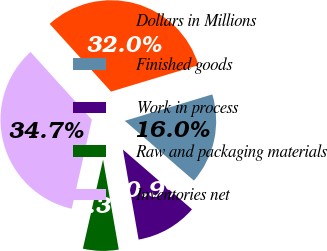<chart> <loc_0><loc_0><loc_500><loc_500><pie_chart><fcel>Dollars in Millions<fcel>Finished goods<fcel>Work in process<fcel>Raw and packaging materials<fcel>Inventories net<nl><fcel>32.05%<fcel>16.02%<fcel>10.9%<fcel>6.29%<fcel>34.74%<nl></chart> 